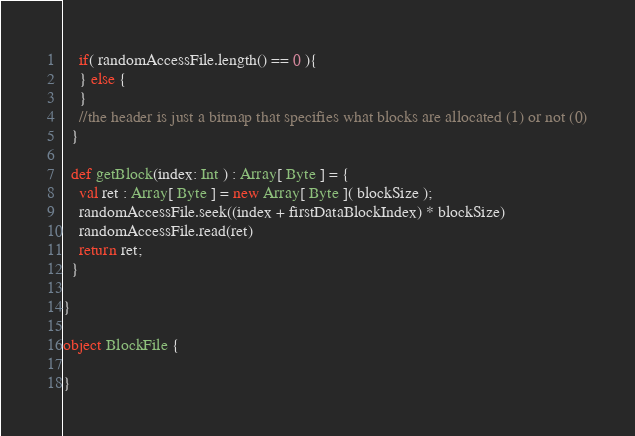<code> <loc_0><loc_0><loc_500><loc_500><_Scala_>    if( randomAccessFile.length() == 0 ){
    } else {
    }
    //the header is just a bitmap that specifies what blocks are allocated (1) or not (0)
  }

  def getBlock(index: Int ) : Array[ Byte ] = {
    val ret : Array[ Byte ] = new Array[ Byte ]( blockSize );
    randomAccessFile.seek((index + firstDataBlockIndex) * blockSize)
    randomAccessFile.read(ret)
    return ret;
  }

}

object BlockFile {

}</code> 